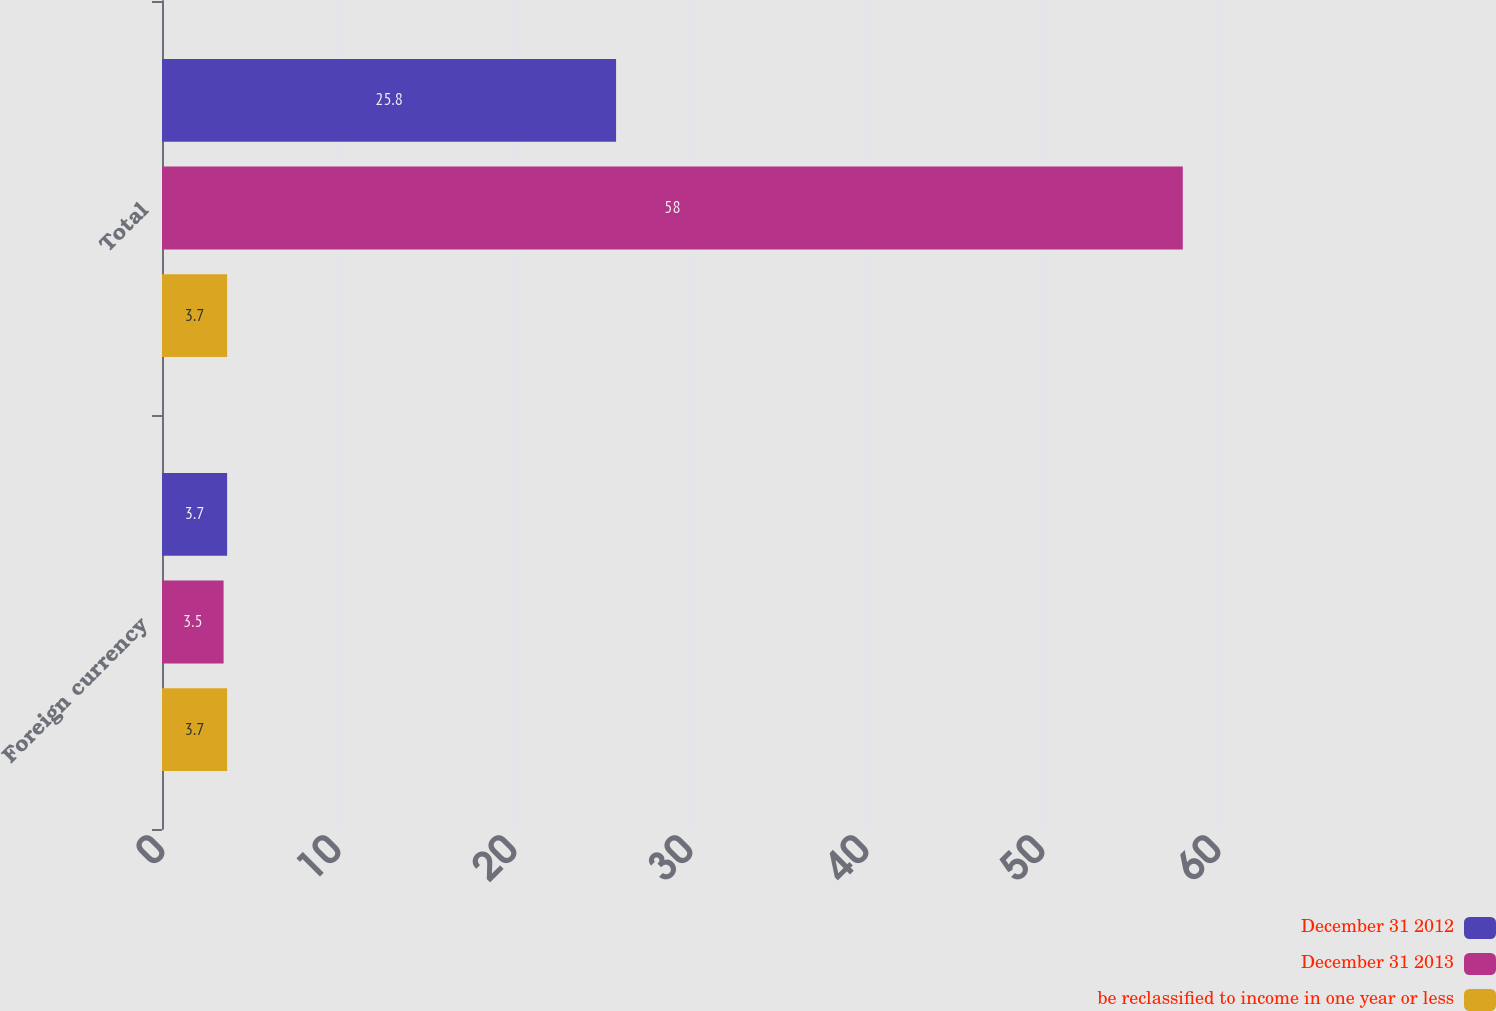<chart> <loc_0><loc_0><loc_500><loc_500><stacked_bar_chart><ecel><fcel>Foreign currency<fcel>Total<nl><fcel>December 31 2012<fcel>3.7<fcel>25.8<nl><fcel>December 31 2013<fcel>3.5<fcel>58<nl><fcel>be reclassified to income in one year or less<fcel>3.7<fcel>3.7<nl></chart> 